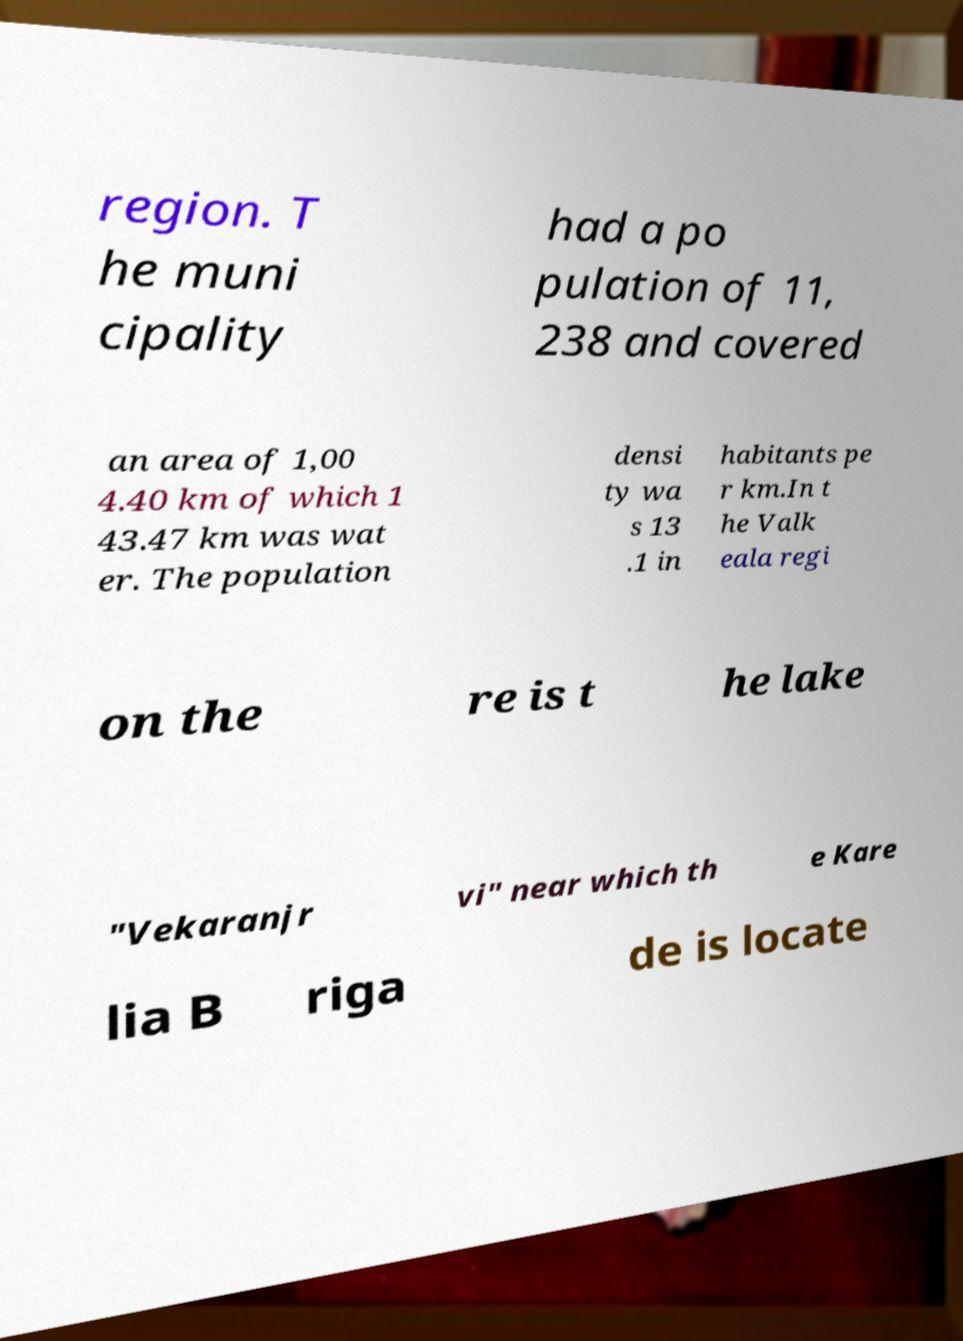I need the written content from this picture converted into text. Can you do that? region. T he muni cipality had a po pulation of 11, 238 and covered an area of 1,00 4.40 km of which 1 43.47 km was wat er. The population densi ty wa s 13 .1 in habitants pe r km.In t he Valk eala regi on the re is t he lake "Vekaranjr vi" near which th e Kare lia B riga de is locate 